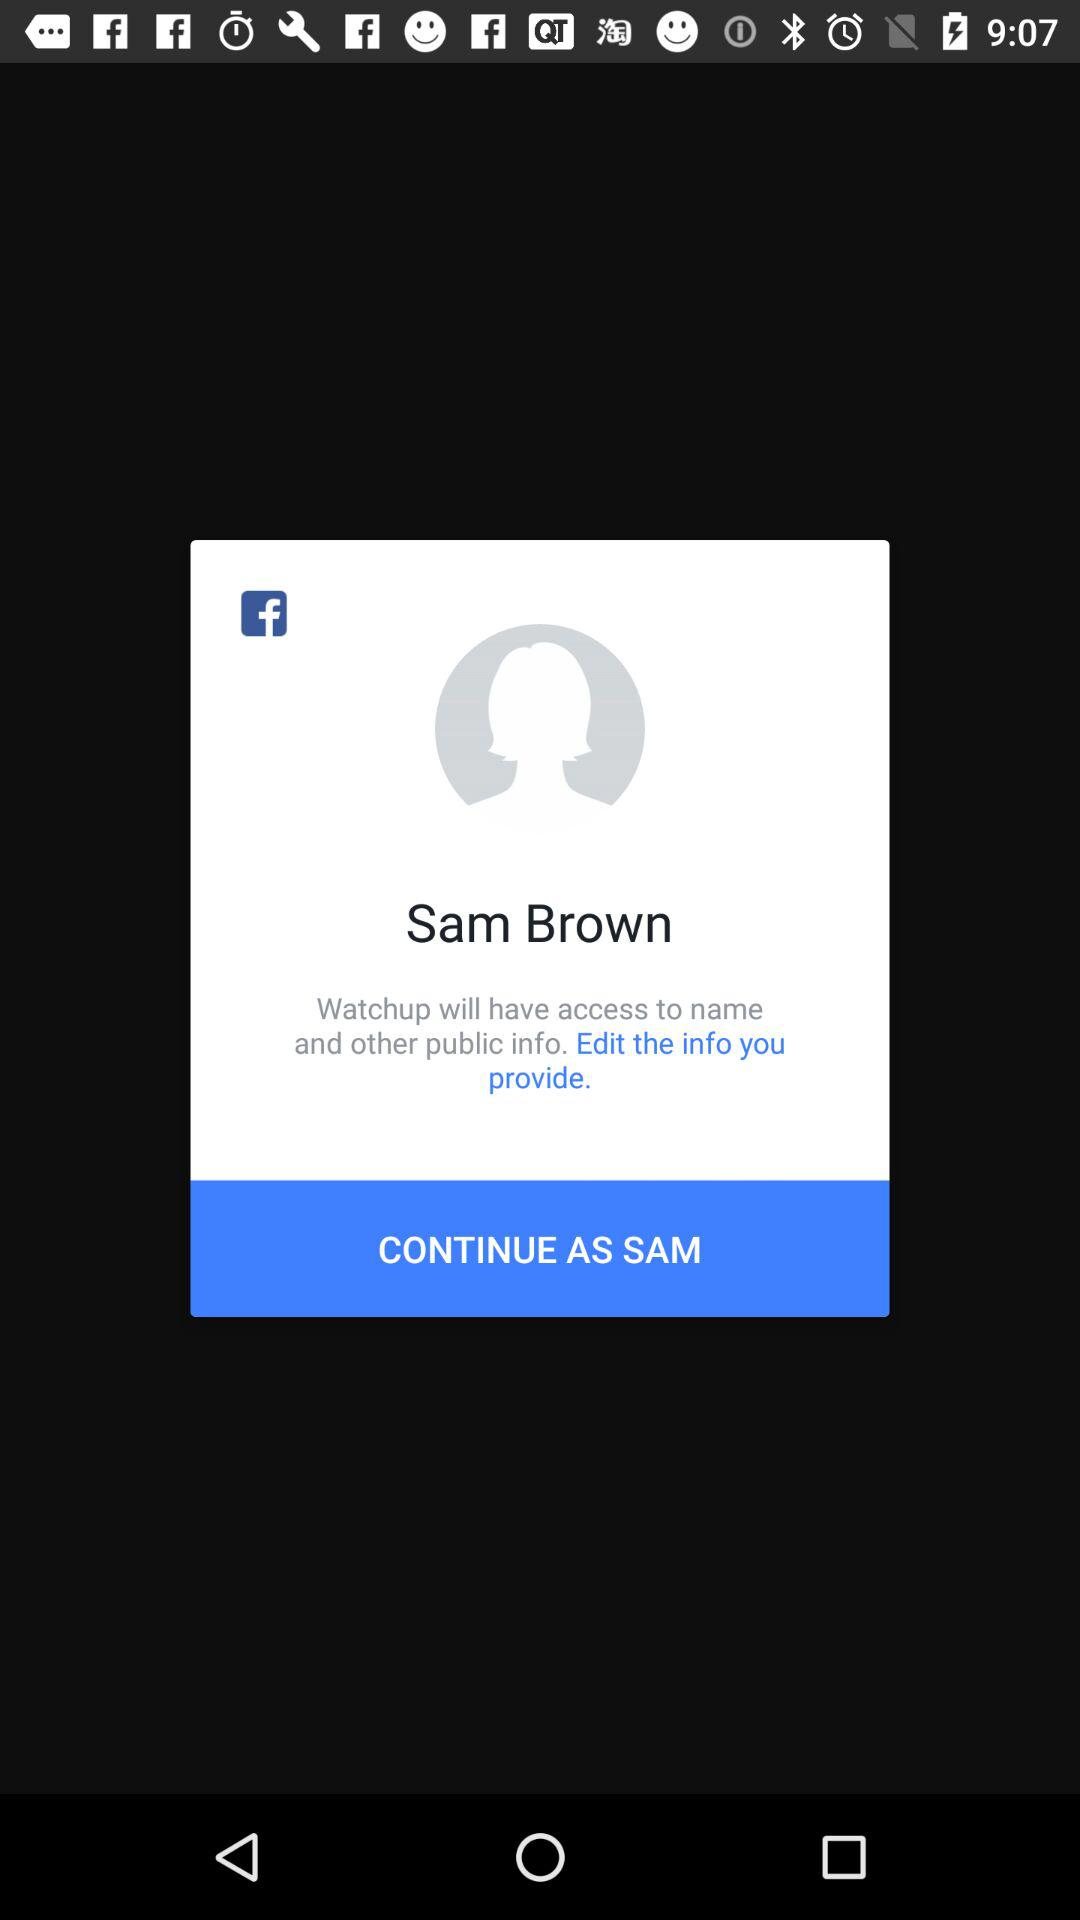What application is asking for permission? The application asking for permission is "Watchup". 